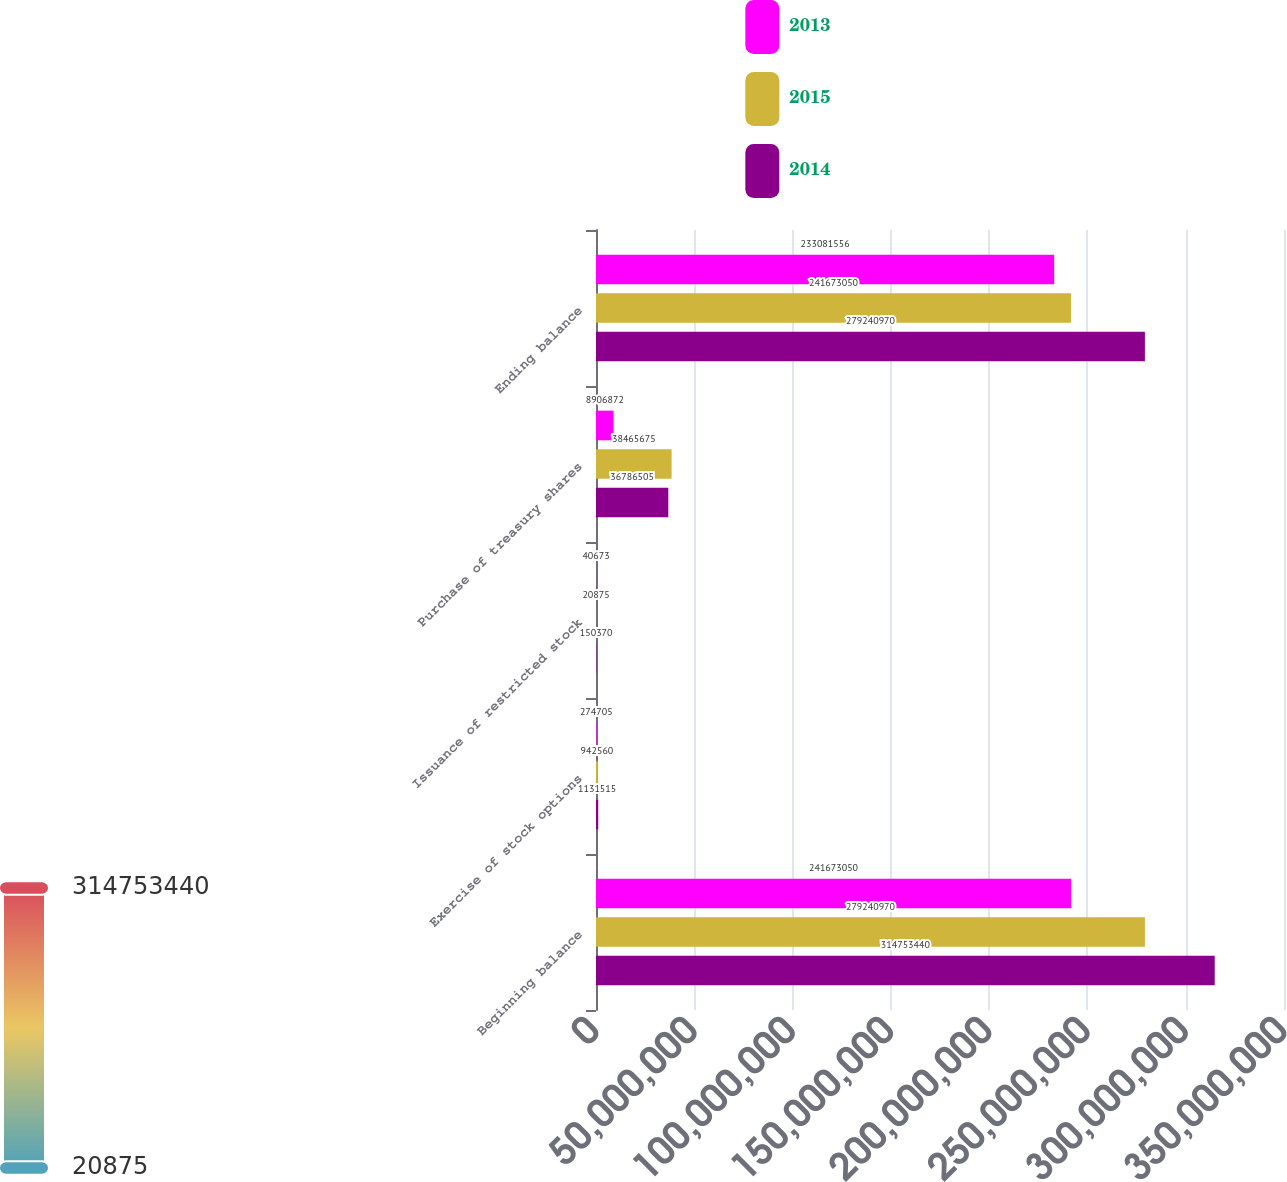Convert chart. <chart><loc_0><loc_0><loc_500><loc_500><stacked_bar_chart><ecel><fcel>Beginning balance<fcel>Exercise of stock options<fcel>Issuance of restricted stock<fcel>Purchase of treasury shares<fcel>Ending balance<nl><fcel>2013<fcel>2.41673e+08<fcel>274705<fcel>40673<fcel>8.90687e+06<fcel>2.33082e+08<nl><fcel>2015<fcel>2.79241e+08<fcel>942560<fcel>20875<fcel>3.84657e+07<fcel>2.41673e+08<nl><fcel>2014<fcel>3.14753e+08<fcel>1.13152e+06<fcel>150370<fcel>3.67865e+07<fcel>2.79241e+08<nl></chart> 